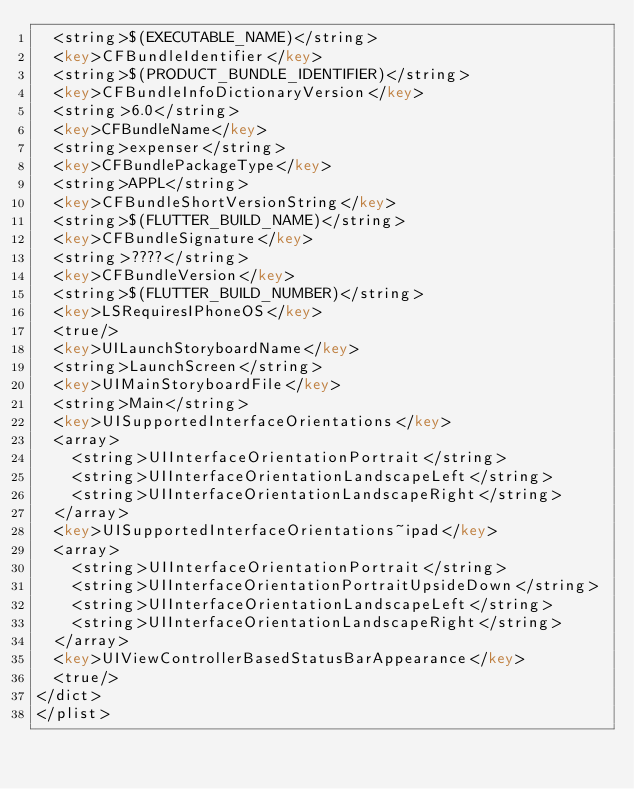Convert code to text. <code><loc_0><loc_0><loc_500><loc_500><_XML_>	<string>$(EXECUTABLE_NAME)</string>
	<key>CFBundleIdentifier</key>
	<string>$(PRODUCT_BUNDLE_IDENTIFIER)</string>
	<key>CFBundleInfoDictionaryVersion</key>
	<string>6.0</string>
	<key>CFBundleName</key>
	<string>expenser</string>
	<key>CFBundlePackageType</key>
	<string>APPL</string>
	<key>CFBundleShortVersionString</key>
	<string>$(FLUTTER_BUILD_NAME)</string>
	<key>CFBundleSignature</key>
	<string>????</string>
	<key>CFBundleVersion</key>
	<string>$(FLUTTER_BUILD_NUMBER)</string>
	<key>LSRequiresIPhoneOS</key>
	<true/>
	<key>UILaunchStoryboardName</key>
	<string>LaunchScreen</string>
	<key>UIMainStoryboardFile</key>
	<string>Main</string>
	<key>UISupportedInterfaceOrientations</key>
	<array>
		<string>UIInterfaceOrientationPortrait</string>
		<string>UIInterfaceOrientationLandscapeLeft</string>
		<string>UIInterfaceOrientationLandscapeRight</string>
	</array>
	<key>UISupportedInterfaceOrientations~ipad</key>
	<array>
		<string>UIInterfaceOrientationPortrait</string>
		<string>UIInterfaceOrientationPortraitUpsideDown</string>
		<string>UIInterfaceOrientationLandscapeLeft</string>
		<string>UIInterfaceOrientationLandscapeRight</string>
	</array>
	<key>UIViewControllerBasedStatusBarAppearance</key>
	<true/>
</dict>
</plist>
</code> 